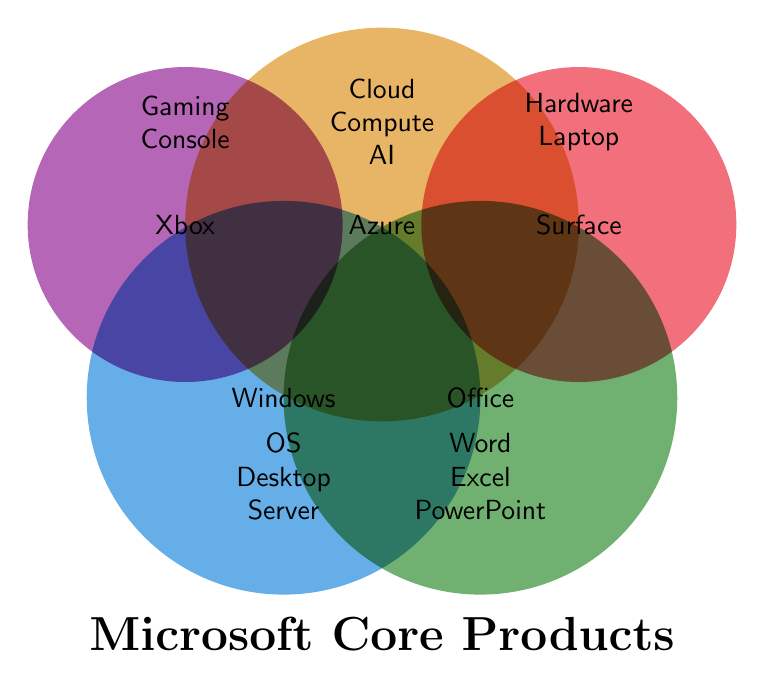What is the central theme of the figure? The figure highlights Microsoft's core product lines, showing a Venn Diagram representation of various product categories and features.
Answer: Microsoft's core product lines Which product line is represented by the blue circle? The blue circle contains the text "Windows," indicating that it represents the Windows product line.
Answer: Windows How many features are listed for the Office product line? By checking the green circle associated with the Office product line, it contains "Word," "Excel," and "PowerPoint," totaling three features.
Answer: Three Which product lines share the feature 'Tablet'? The blue circle (Windows) lists "Tablet" and the orange circle (Surface) lists "Tablet," showing that both Windows and Surface include this feature.
Answer: Windows and Surface Name a product line and a feature that are not associated with the 'Gaming' category. The 'Gaming' category is represented by the purple circle for Xbox. Checking other areas, the Office product line and the feature "Word" are not associated with 'Gaming.'
Answer: Office, Word What is common between the features listed under Windows and Surface product lines? Both Windows and Surface product lines include the feature "Tablet" as listed in their respective circles.
Answer: Tablet Compare the number of features in the Office and Azure product lines. Which has more? The Office product line (green circle) lists three features (Word, Excel, PowerPoint), whereas the Azure product line (orange circle) lists three features (Cloud, Compute, AI). Therefore, both have the same number of features.
Answer: Equal Which product line is related to both 'Cloud' and 'AI'? Checking the text within the surrounding circles, the Azure product line (orange circle) specifically mentions "Cloud" and "AI."
Answer: Azure What business functions are covered by the Dynamics product line features? Dynamics product line features include CRM and ERP, as given in the data. Both relate to business functions, specifically Customer Relationship Management and Enterprise Resource Planning.
Answer: CRM and ERP Is there any feature overlap between the Surface and Dynamics product lines? Reviewing the features listed in the circles for Surface (Hardware, Tablet) and Dynamics (CRM, ERP), there are no common features between these two product lines.
Answer: No 